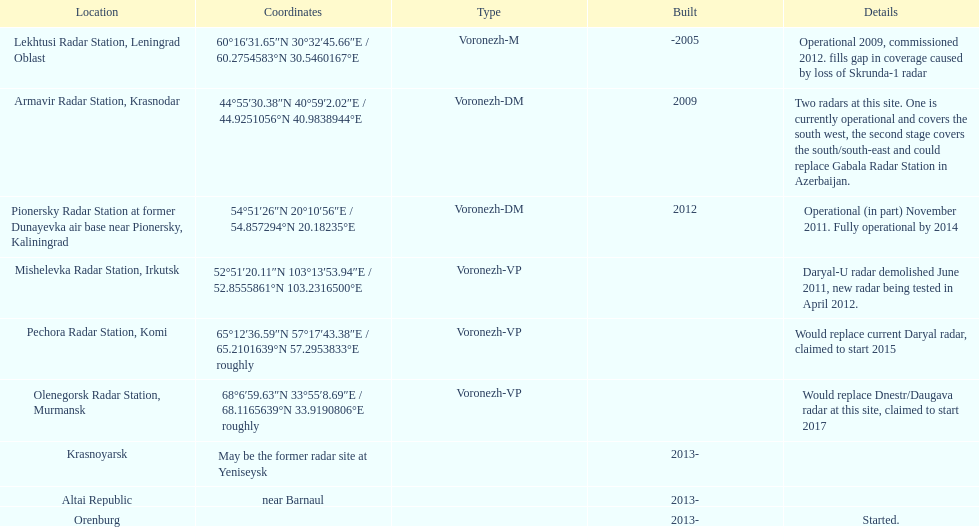How many voronezh radars are present in kaliningrad or krasnodar? 2. 